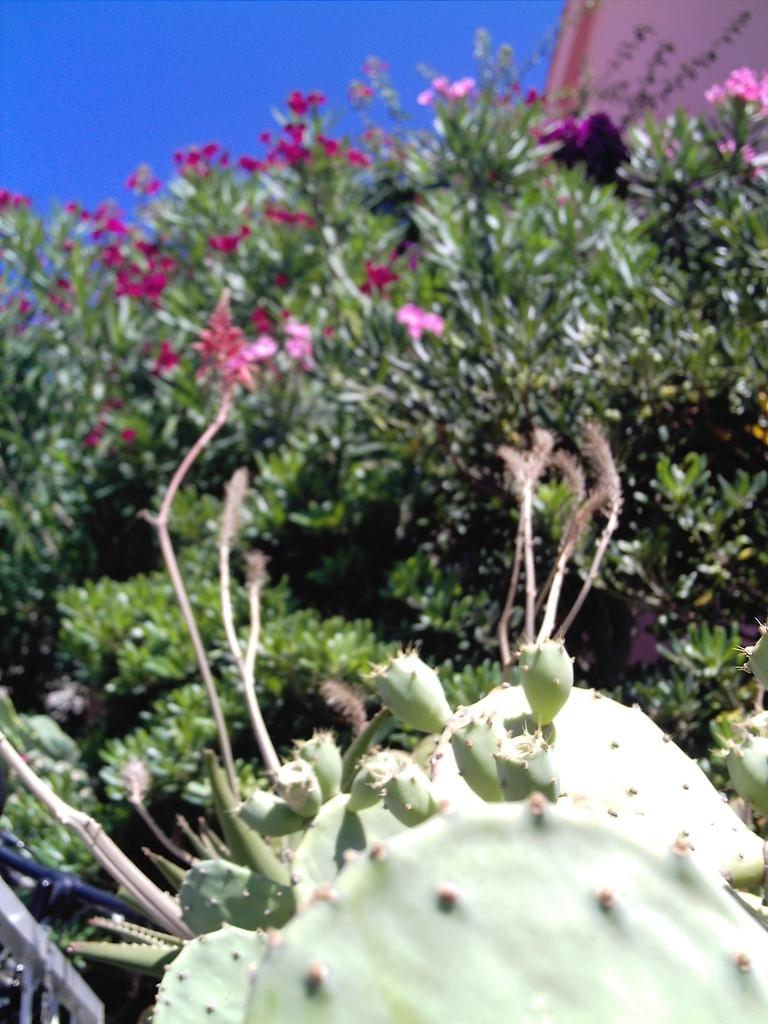What type of plants are at the bottom of the image? There are cactus plants at the bottom of the image. What can be seen in the background of the image? There are trees, flowers, and the sky visible in the background of the image. What type of beef can be seen in the image? There is no beef present in the image. What source of power is visible in the image? There is no power source visible in the image. 